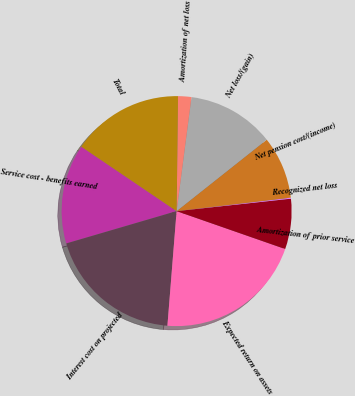Convert chart to OTSL. <chart><loc_0><loc_0><loc_500><loc_500><pie_chart><fcel>Service cost - benefits earned<fcel>Interest cost on projected<fcel>Expected return on assets<fcel>Amortization of prior service<fcel>Recognized net loss<fcel>Net pension cost/(income)<fcel>Net loss/(gain)<fcel>Amortization of net loss<fcel>Total<nl><fcel>14.0%<fcel>19.19%<fcel>20.93%<fcel>7.07%<fcel>0.14%<fcel>8.8%<fcel>12.27%<fcel>1.87%<fcel>15.73%<nl></chart> 